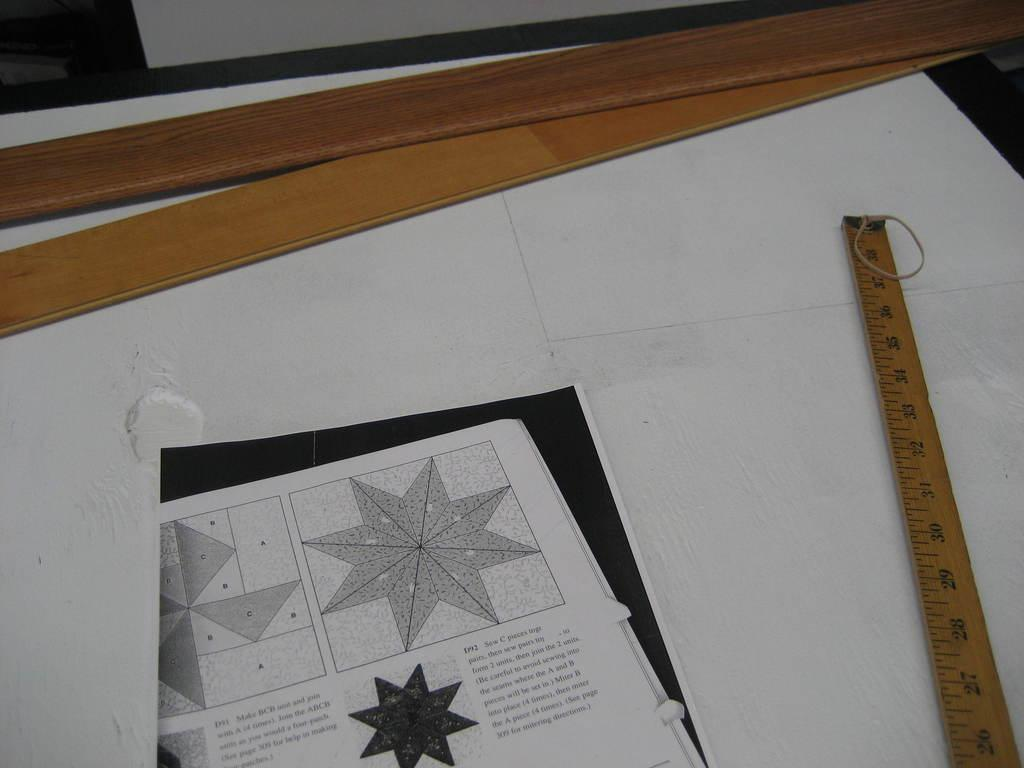<image>
Describe the image concisely. A measuring tape that goes up to 38 inches is laid on a table. 